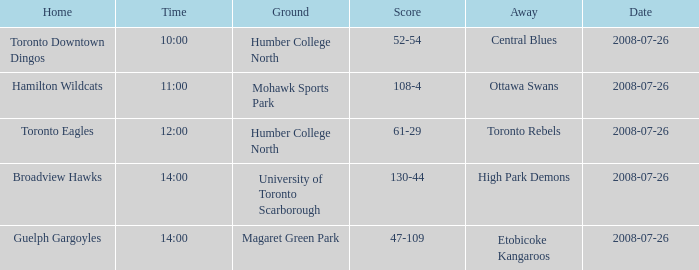Who has the Home Score of 52-54? Toronto Downtown Dingos. 